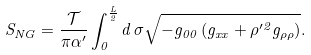<formula> <loc_0><loc_0><loc_500><loc_500>S _ { N G } = \frac { \mathcal { T } } { \pi \alpha ^ { \prime } } \int _ { 0 } ^ { \frac { L } { 2 } } d \, \sigma \sqrt { - g _ { 0 0 } \left ( g _ { x x } + \rho ^ { \prime 2 } g _ { \rho \rho } \right ) } .</formula> 